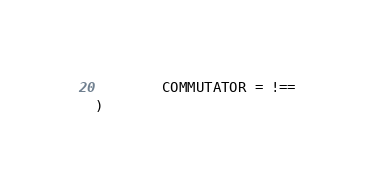<code> <loc_0><loc_0><loc_500><loc_500><_SQL_>        COMMUTATOR = !==
)
</code> 